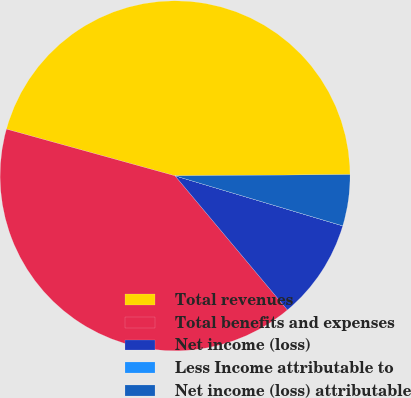<chart> <loc_0><loc_0><loc_500><loc_500><pie_chart><fcel>Total revenues<fcel>Total benefits and expenses<fcel>Net income (loss)<fcel>Less Income attributable to<fcel>Net income (loss) attributable<nl><fcel>45.59%<fcel>40.4%<fcel>9.28%<fcel>0.01%<fcel>4.72%<nl></chart> 